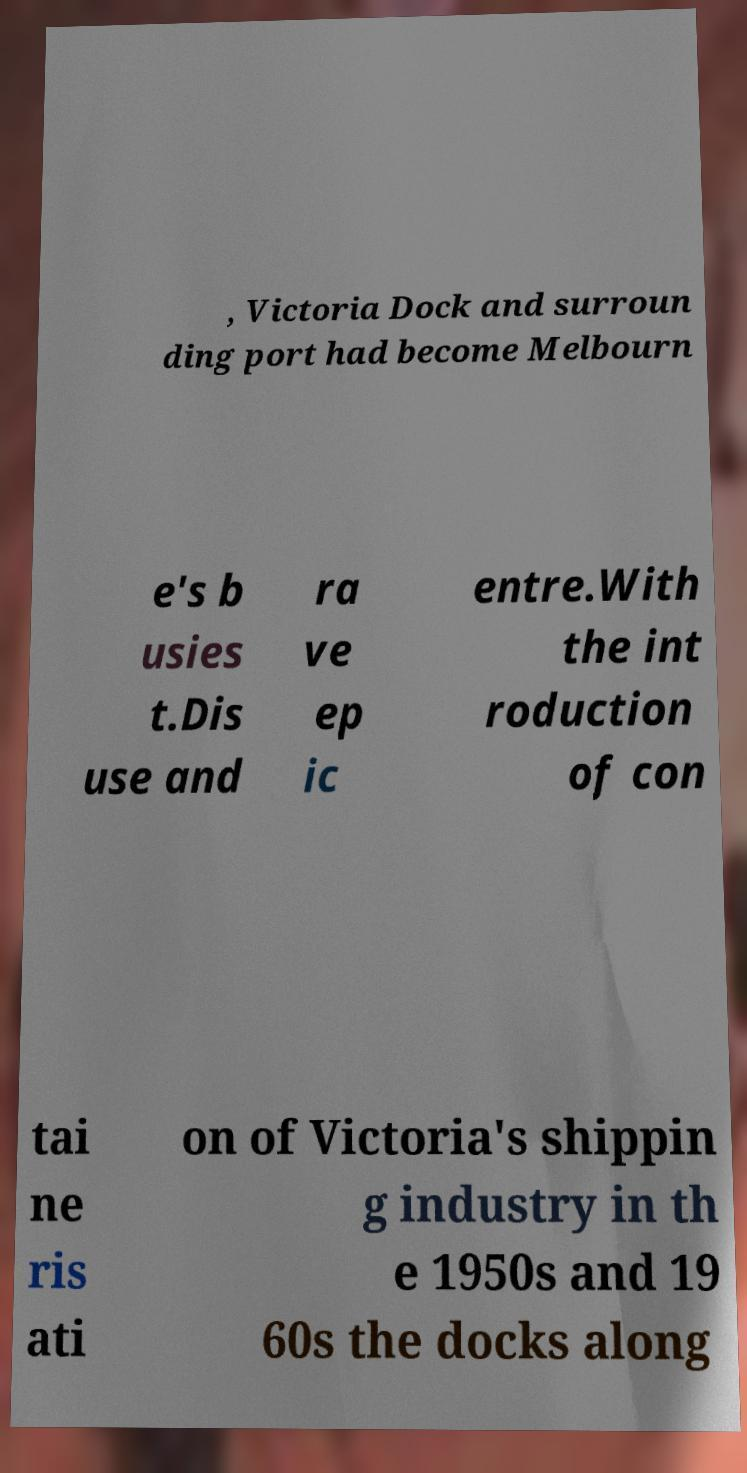Please read and relay the text visible in this image. What does it say? , Victoria Dock and surroun ding port had become Melbourn e's b usies t.Dis use and ra ve ep ic entre.With the int roduction of con tai ne ris ati on of Victoria's shippin g industry in th e 1950s and 19 60s the docks along 